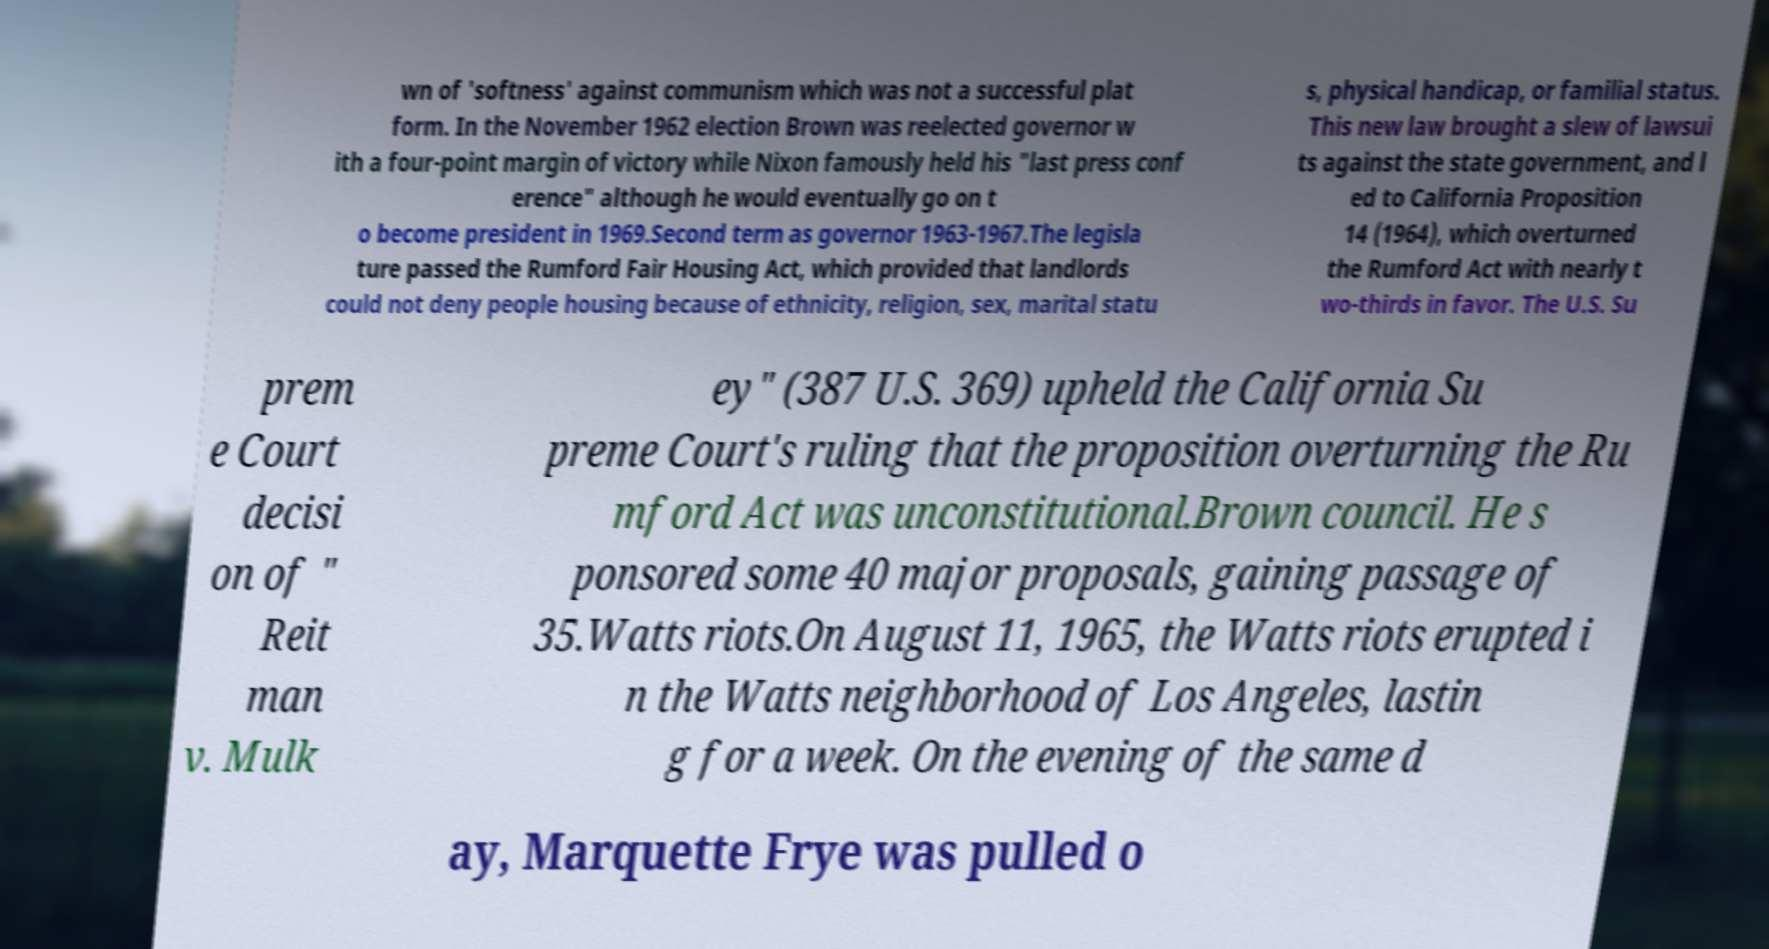What messages or text are displayed in this image? I need them in a readable, typed format. wn of 'softness' against communism which was not a successful plat form. In the November 1962 election Brown was reelected governor w ith a four-point margin of victory while Nixon famously held his "last press conf erence" although he would eventually go on t o become president in 1969.Second term as governor 1963-1967.The legisla ture passed the Rumford Fair Housing Act, which provided that landlords could not deny people housing because of ethnicity, religion, sex, marital statu s, physical handicap, or familial status. This new law brought a slew of lawsui ts against the state government, and l ed to California Proposition 14 (1964), which overturned the Rumford Act with nearly t wo-thirds in favor. The U.S. Su prem e Court decisi on of " Reit man v. Mulk ey" (387 U.S. 369) upheld the California Su preme Court's ruling that the proposition overturning the Ru mford Act was unconstitutional.Brown council. He s ponsored some 40 major proposals, gaining passage of 35.Watts riots.On August 11, 1965, the Watts riots erupted i n the Watts neighborhood of Los Angeles, lastin g for a week. On the evening of the same d ay, Marquette Frye was pulled o 